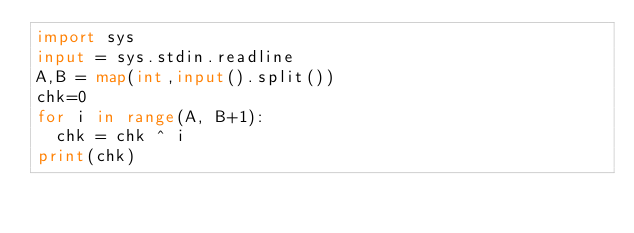Convert code to text. <code><loc_0><loc_0><loc_500><loc_500><_Python_>import sys
input = sys.stdin.readline
A,B = map(int,input().split())
chk=0
for i in range(A, B+1):
  chk = chk ^ i
print(chk)
</code> 